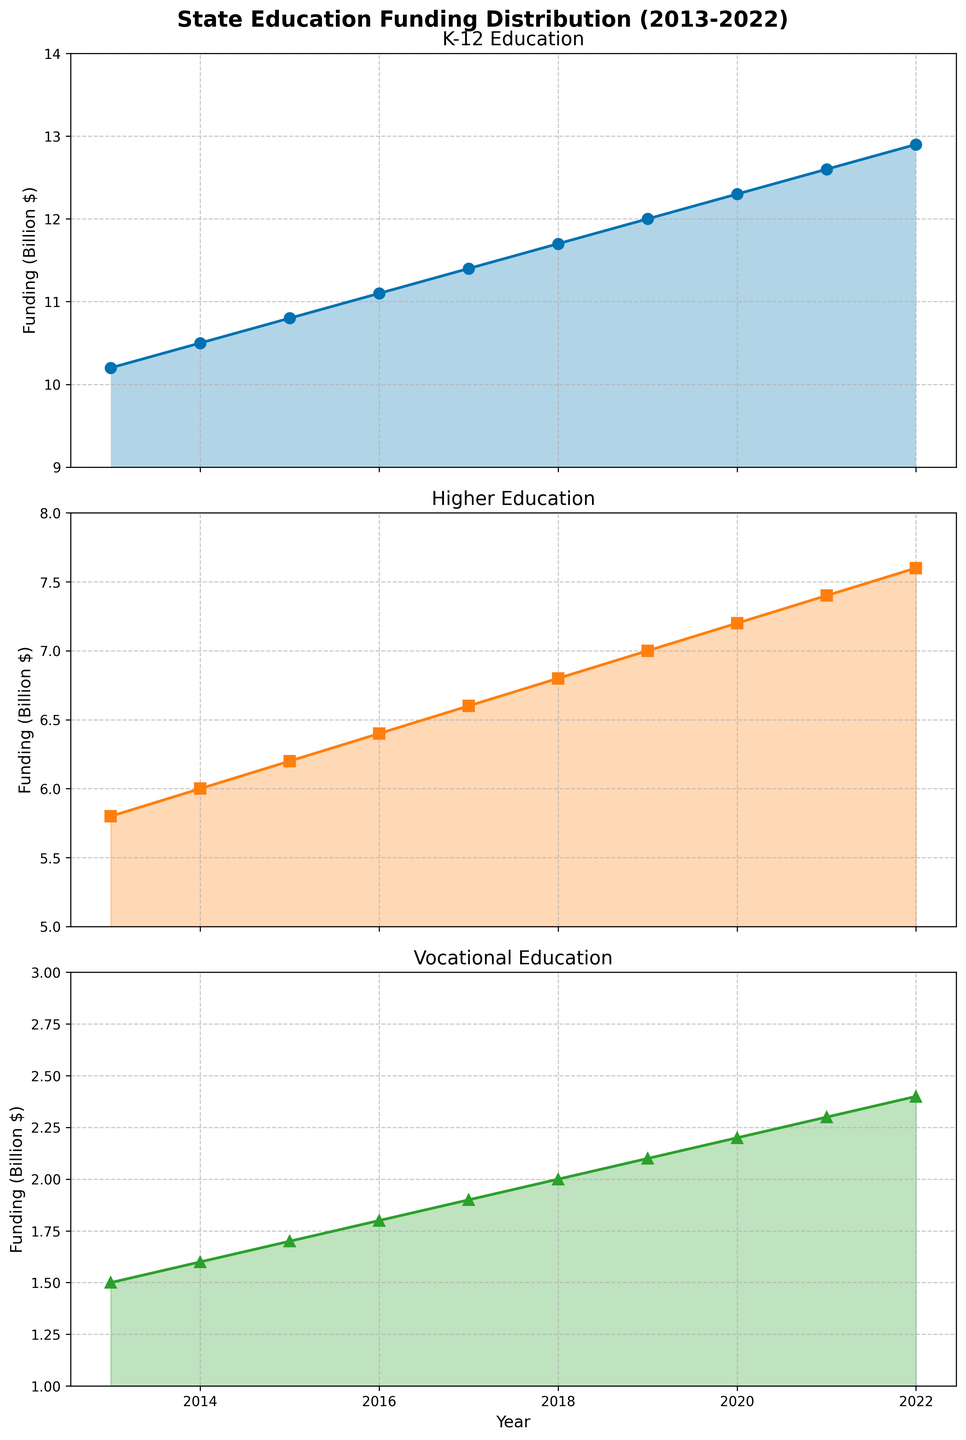What is the title of the figure? At the top of the figure, there is a large text indicating the overall description of the plot. The title is "State Education Funding Distribution (2013-2022)."
Answer: State Education Funding Distribution (2013-2022) Which year had the highest funding for K-12 education? By observing the first subplot, we see that the funding for K-12 education reaches its highest point in the year 2022 at 12.9 billion dollars.
Answer: 2022 What is the color used for the Higher Education funding line? The line color for Higher Education funding is visibly represented by a bright orange color in the second subplot.
Answer: Orange What is the difference in Vocational education funding between 2013 and 2022? Looking at the third subplot, the funding for Vocational education in 2013 is 1.5 billion dollars and in 2022 is 2.4 billion dollars. The difference is calculated by subtracting 1.5 from 2.4, resulting in a difference of 0.9 billion dollars.
Answer: 0.9 billion dollars What is the percentage increase in K-12 education funding from 2013 to 2022? The funding in 2013 was 10.2 billion dollars and in 2022 it was 12.9 billion dollars. The percentage increase can be calculated by ((12.9 - 10.2) / 10.2 ) * 100 = 26.47%.
Answer: 26.47% How does the trend in Higher Education funding compare to K-12 education funding over the years? Both subplots show an increasing trend. However, the rate of increase in K-12 funding is relatively steady and slightly higher compared to Higher Education funding. By 2022, K-12 education funding shows a larger absolute increase than Higher Education.
Answer: K-12 increases more Which year had the smallest gap between Higher Education and Vocational education funding? By examining the second and third subplots together, the smallest gap appears in 2013 with Higher Education at 5.8 billion dollars and Vocational education at 1.5 billion dollars, making the gap 4.3 billion dollars.
Answer: 2013 What can you infer about the overall funding trend for Vocational education? From the third subplot, it is evident that Vocational education funding shows a consistent and steady increase over the decade from 1.5 billion dollars in 2013 to 2.4 billion dollars in 2022.
Answer: Steady increase Calculate the average funding for Higher Education over the presented decade. To find the average, sum all the annual funding values for Higher Education: 5.8 + 6.0 + 6.2 + 6.4 + 6.6 + 6.8 + 7.0 + 7.2 + 7.4 + 7.6 = 66. Along 10 years, the average is 66 / 10 = 6.6 billion dollars.
Answer: 6.6 billion dollars Which type of education funding had the smallest increase over the decade? Comparing all three subplots, Vocational education shows the smallest absolute increase from 1.5 billion dollars in 2013 to 2.4 billion dollars in 2022, which is a 0.9 billion dollars increase.
Answer: Vocational education 